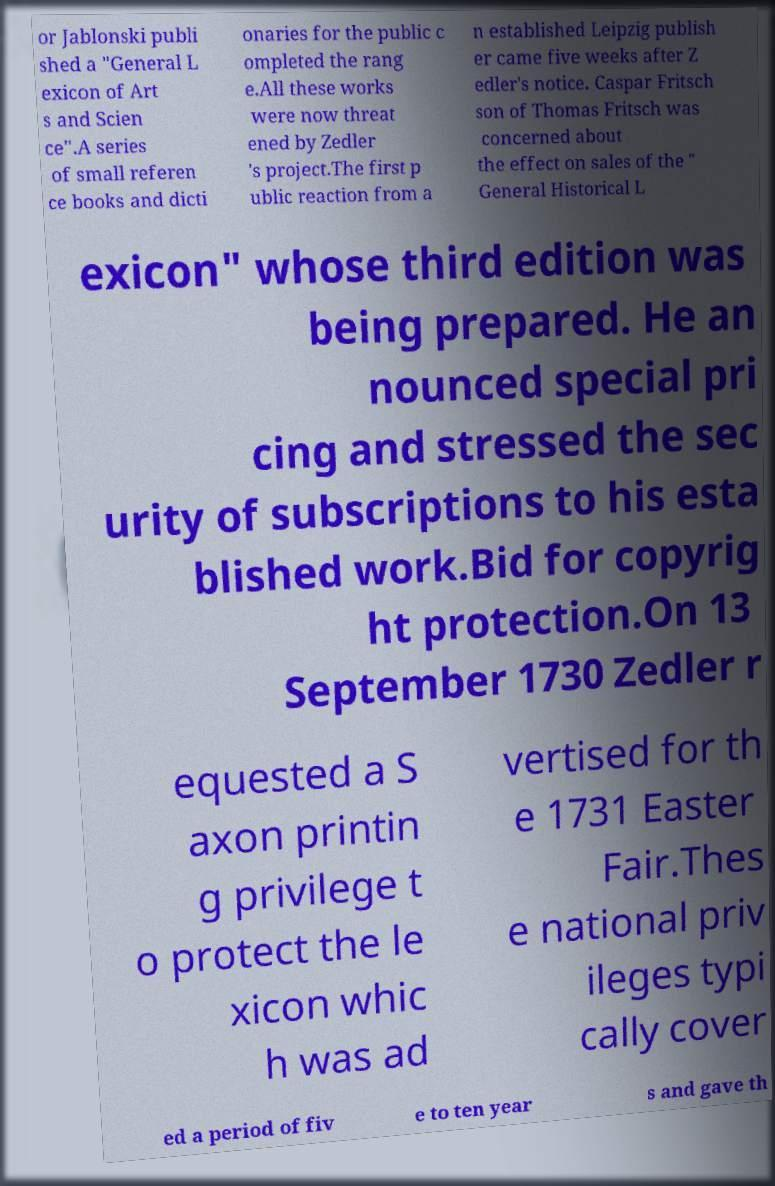Could you assist in decoding the text presented in this image and type it out clearly? or Jablonski publi shed a "General L exicon of Art s and Scien ce".A series of small referen ce books and dicti onaries for the public c ompleted the rang e.All these works were now threat ened by Zedler 's project.The first p ublic reaction from a n established Leipzig publish er came five weeks after Z edler's notice. Caspar Fritsch son of Thomas Fritsch was concerned about the effect on sales of the " General Historical L exicon" whose third edition was being prepared. He an nounced special pri cing and stressed the sec urity of subscriptions to his esta blished work.Bid for copyrig ht protection.On 13 September 1730 Zedler r equested a S axon printin g privilege t o protect the le xicon whic h was ad vertised for th e 1731 Easter Fair.Thes e national priv ileges typi cally cover ed a period of fiv e to ten year s and gave th 